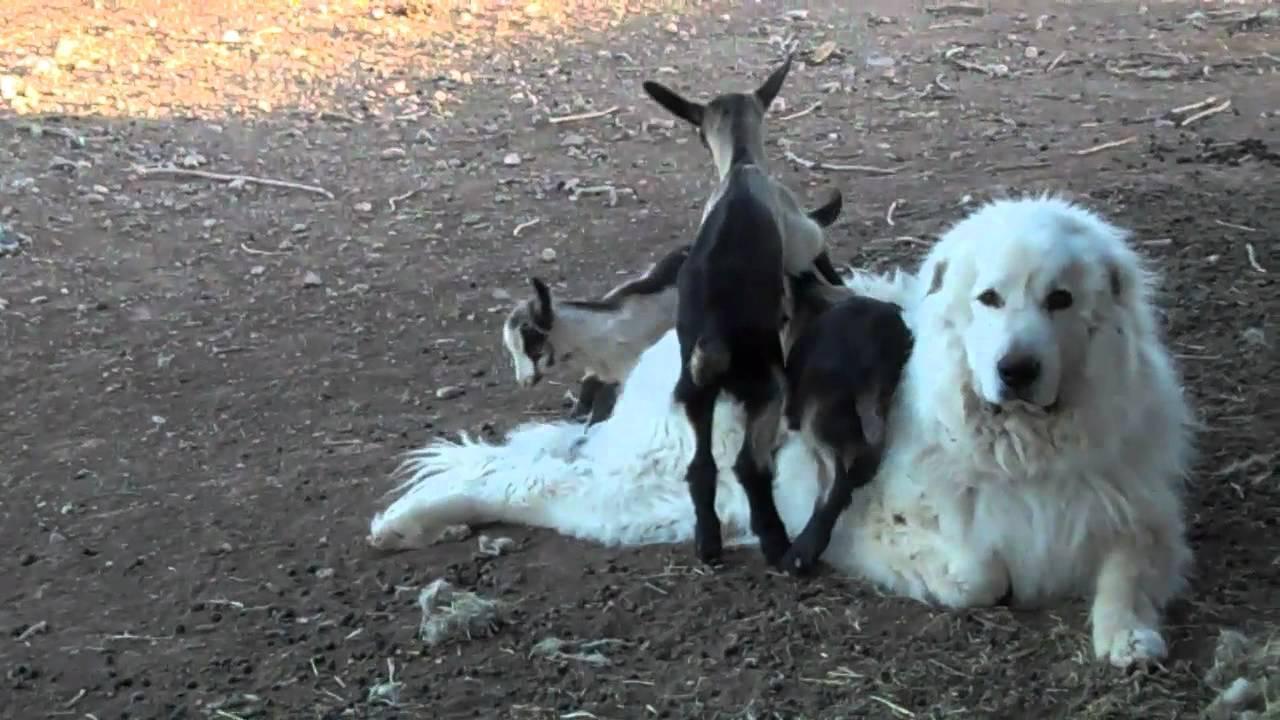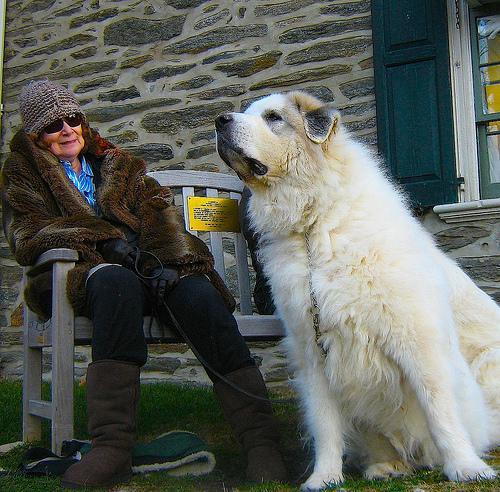The first image is the image on the left, the second image is the image on the right. Assess this claim about the two images: "There are at least 3 dogs.". Correct or not? Answer yes or no. No. The first image is the image on the left, the second image is the image on the right. Given the left and right images, does the statement "Right image shows an older person next to a large dog." hold true? Answer yes or no. Yes. 